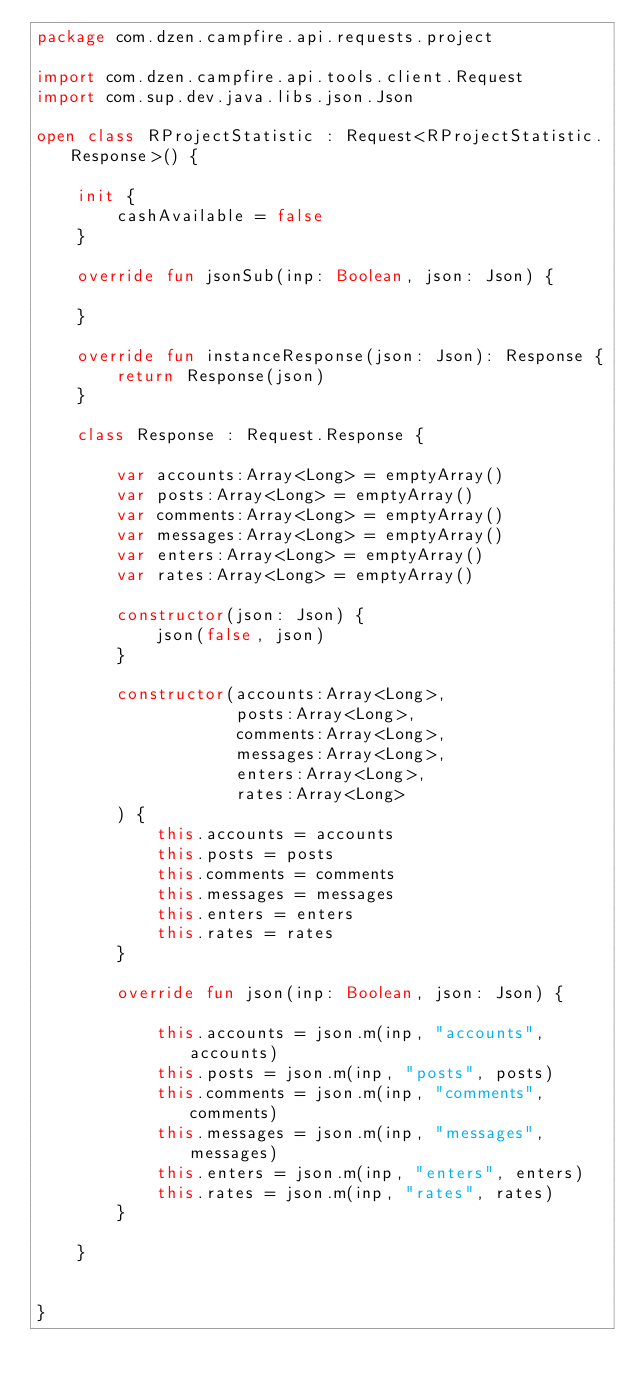<code> <loc_0><loc_0><loc_500><loc_500><_Kotlin_>package com.dzen.campfire.api.requests.project

import com.dzen.campfire.api.tools.client.Request
import com.sup.dev.java.libs.json.Json

open class RProjectStatistic : Request<RProjectStatistic.Response>() {

    init {
        cashAvailable = false
    }

    override fun jsonSub(inp: Boolean, json: Json) {

    }

    override fun instanceResponse(json: Json): Response {
        return Response(json)
    }

    class Response : Request.Response {

        var accounts:Array<Long> = emptyArray()
        var posts:Array<Long> = emptyArray()
        var comments:Array<Long> = emptyArray()
        var messages:Array<Long> = emptyArray()
        var enters:Array<Long> = emptyArray()
        var rates:Array<Long> = emptyArray()

        constructor(json: Json) {
            json(false, json)
        }

        constructor(accounts:Array<Long>,
                    posts:Array<Long>,
                    comments:Array<Long>,
                    messages:Array<Long>,
                    enters:Array<Long>,
                    rates:Array<Long>
        ) {
            this.accounts = accounts
            this.posts = posts
            this.comments = comments
            this.messages = messages
            this.enters = enters
            this.rates = rates
        }

        override fun json(inp: Boolean, json: Json) {

            this.accounts = json.m(inp, "accounts", accounts)
            this.posts = json.m(inp, "posts", posts)
            this.comments = json.m(inp, "comments", comments)
            this.messages = json.m(inp, "messages", messages)
            this.enters = json.m(inp, "enters", enters)
            this.rates = json.m(inp, "rates", rates)
        }

    }


}</code> 